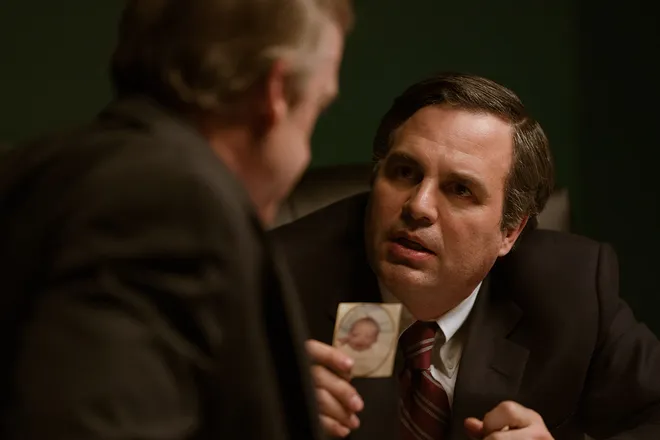What are the key elements in this picture? This image portrays a tense scene from the movie 'Dark Waters', featuring a character played by the actor often cast in roles of everyday heroes. The key elements include the dimly lit, greenish-toned office which creates a somber and intense atmosphere, suggesting the gravity of the conversation taking place. The central figure is depicted leaning forward earnestly, engaging with another character who holds a photograph, adding to the suspense and indicating a pivotal moment in their discussion. The photograph, a faded picture of a younger individual, indicates a personal stake in the conversation, vastly increasing the scene's emotional impact. 